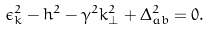Convert formula to latex. <formula><loc_0><loc_0><loc_500><loc_500>\epsilon _ { k } ^ { 2 } - h ^ { 2 } - \gamma ^ { 2 } k _ { \perp } ^ { 2 } + \Delta _ { a b } ^ { 2 } = 0 .</formula> 